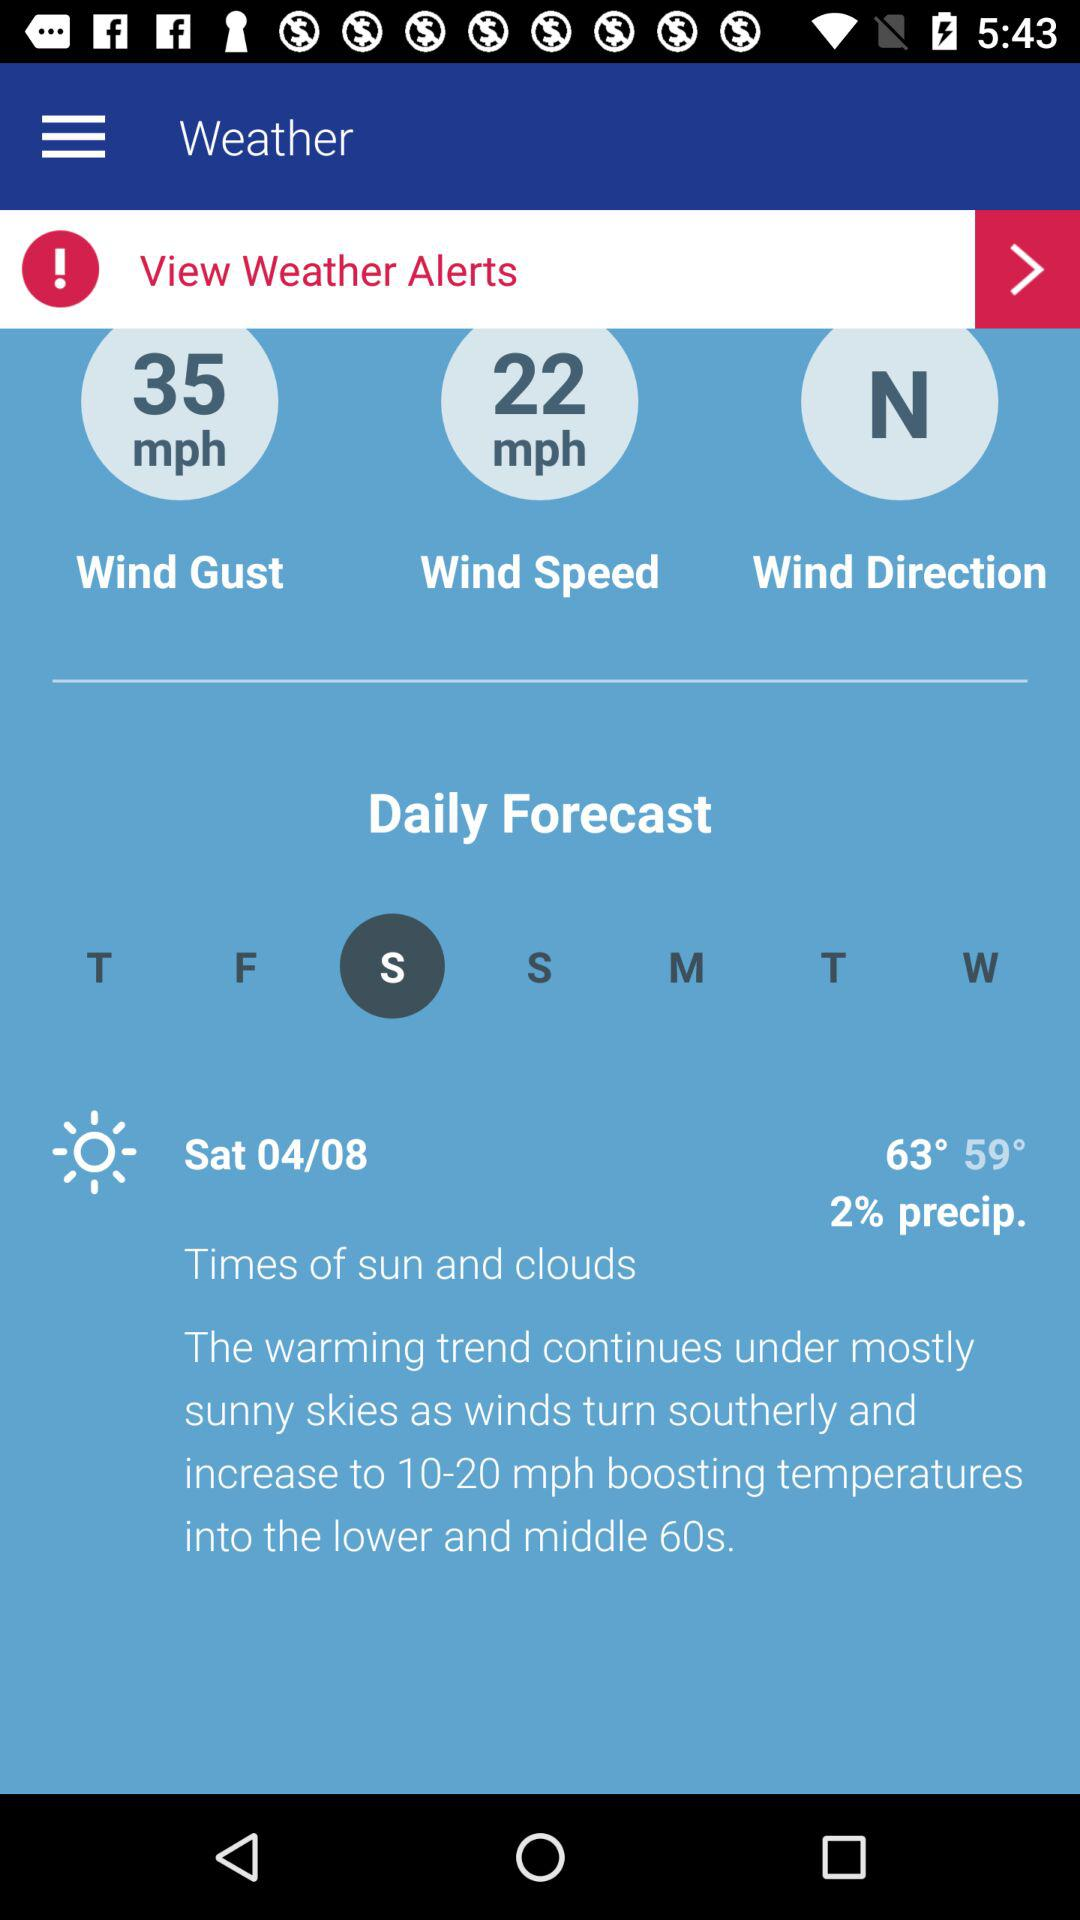What is the percent chance of precipitation for the day?
Answer the question using a single word or phrase. 2% 